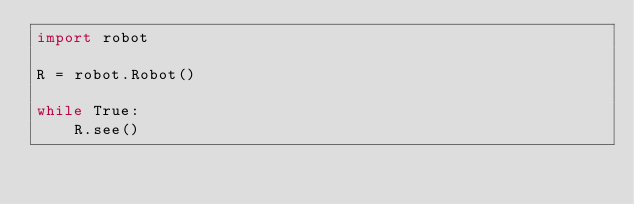<code> <loc_0><loc_0><loc_500><loc_500><_Python_>import robot

R = robot.Robot()

while True:
    R.see()
</code> 